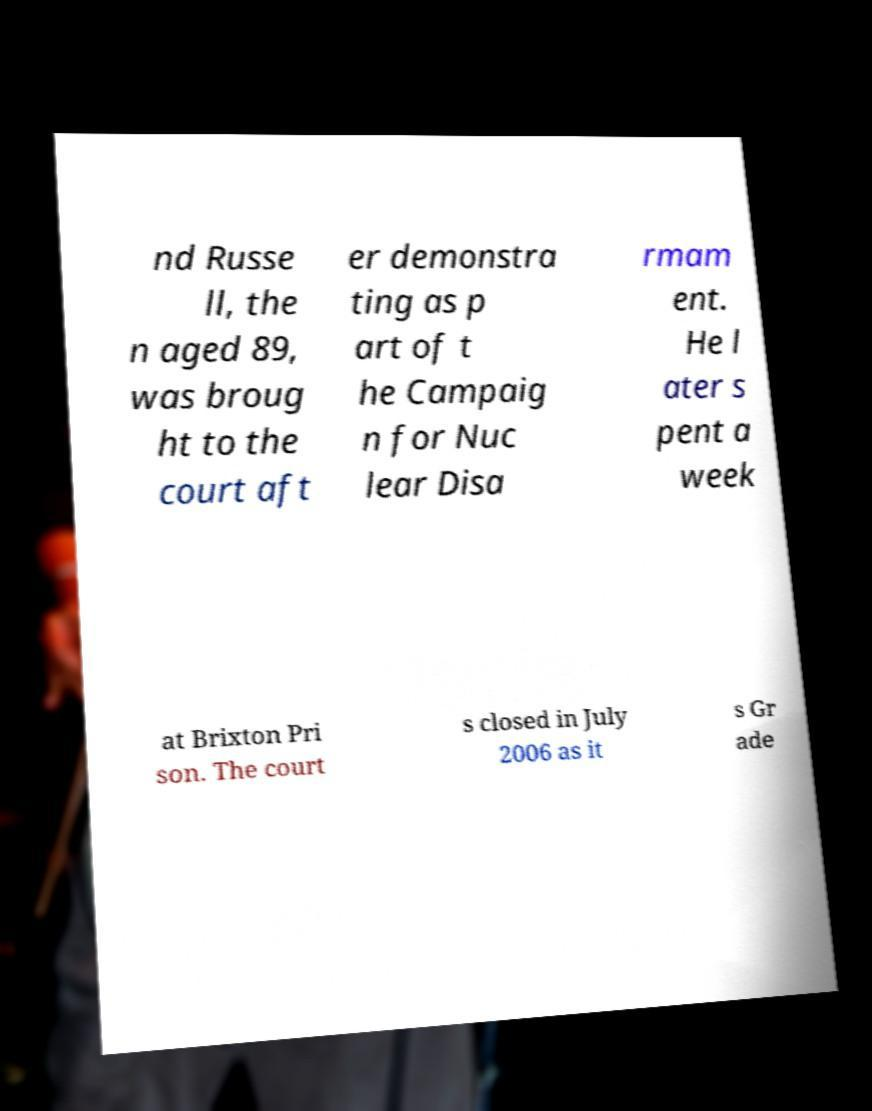I need the written content from this picture converted into text. Can you do that? nd Russe ll, the n aged 89, was broug ht to the court aft er demonstra ting as p art of t he Campaig n for Nuc lear Disa rmam ent. He l ater s pent a week at Brixton Pri son. The court s closed in July 2006 as it s Gr ade 